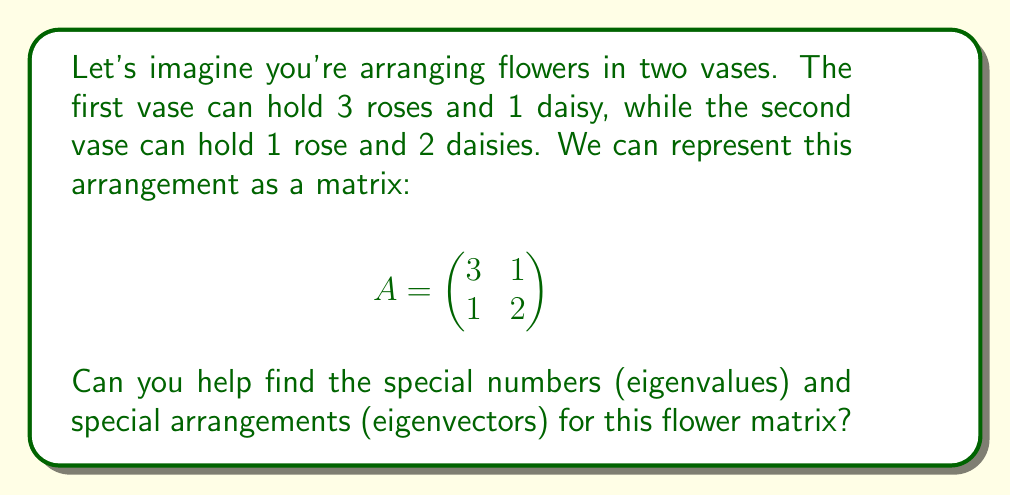Could you help me with this problem? Let's break this down into simple steps:

1) To find eigenvalues, we use the characteristic equation:
   $det(A - \lambda I) = 0$
   
   Where $I$ is the 2x2 identity matrix and $\lambda$ represents the eigenvalues.

2) Let's expand this:
   $$det\begin{pmatrix}
   3-\lambda & 1 \\
   1 & 2-\lambda
   \end{pmatrix} = 0$$

3) Calculate the determinant:
   $(3-\lambda)(2-\lambda) - 1 \cdot 1 = 0$

4) Simplify:
   $6 - 5\lambda + \lambda^2 - 1 = 0$
   $\lambda^2 - 5\lambda + 5 = 0$

5) This is a quadratic equation. We can solve it using the quadratic formula:
   $\lambda = \frac{5 \pm \sqrt{25 - 20}}{2} = \frac{5 \pm \sqrt{5}}{2}$

6) So, our eigenvalues are:
   $\lambda_1 = \frac{5 + \sqrt{5}}{2}$ and $\lambda_2 = \frac{5 - \sqrt{5}}{2}$

7) For each eigenvalue, we find the corresponding eigenvector $v$ by solving:
   $(A - \lambda I)v = 0$

8) For $\lambda_1 = \frac{5 + \sqrt{5}}{2}$:
   $$\begin{pmatrix}
   3-\frac{5 + \sqrt{5}}{2} & 1 \\
   1 & 2-\frac{5 + \sqrt{5}}{2}
   \end{pmatrix}\begin{pmatrix}
   x \\
   y
   \end{pmatrix} = \begin{pmatrix}
   0 \\
   0
   \end{pmatrix}$$

9) Solving this, we get: $x = 1$, $y = \frac{\sqrt{5}-1}{2}$

10) Similarly, for $\lambda_2 = \frac{5 - \sqrt{5}}{2}$, we get:
    $x = 1$, $y = -\frac{\sqrt{5}+1}{2}$

Therefore, our eigenvectors are:
$v_1 = \begin{pmatrix} 1 \\ \frac{\sqrt{5}-1}{2} \end{pmatrix}$ and
$v_2 = \begin{pmatrix} 1 \\ -\frac{\sqrt{5}+1}{2} \end{pmatrix}$
Answer: Eigenvalues: $\lambda_1 = \frac{5 + \sqrt{5}}{2}$, $\lambda_2 = \frac{5 - \sqrt{5}}{2}$
Eigenvectors: $v_1 = \begin{pmatrix} 1 \\ \frac{\sqrt{5}-1}{2} \end{pmatrix}$, $v_2 = \begin{pmatrix} 1 \\ -\frac{\sqrt{5}+1}{2} \end{pmatrix}$ 